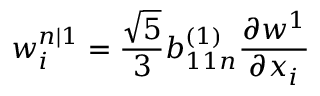Convert formula to latex. <formula><loc_0><loc_0><loc_500><loc_500>w _ { i } ^ { n | 1 } = \frac { \sqrt { 5 } } { 3 } b _ { 1 1 n } ^ { ( 1 ) } \frac { \partial w ^ { 1 } } { \partial x _ { i } }</formula> 